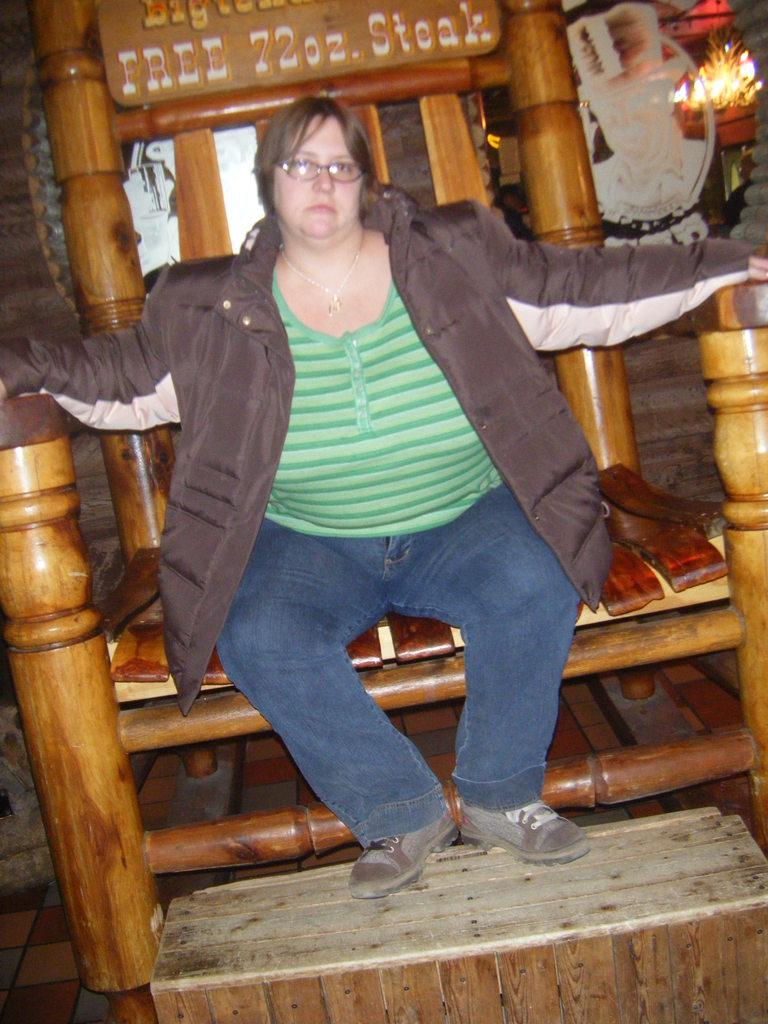What is the main subject of the image? There is a fat lady in the image. What is the lady doing in the image? The lady is sitting in a big chair. What accessory is the lady wearing in the image? The lady is wearing spectacles. What type of disease is the lady suffering from in the image? There is no indication of any disease in the image; it only shows a fat lady sitting in a big chair and wearing spectacles. 